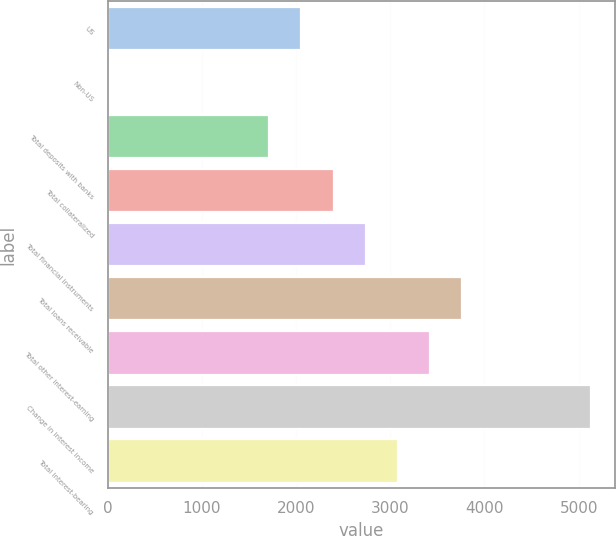<chart> <loc_0><loc_0><loc_500><loc_500><bar_chart><fcel>US<fcel>Non-US<fcel>Total deposits with banks<fcel>Total collateralized<fcel>Total financial instruments<fcel>Total loans receivable<fcel>Total other interest-earning<fcel>Change in interest income<fcel>Total interest-bearing<nl><fcel>2057.6<fcel>11<fcel>1716.5<fcel>2398.7<fcel>2739.8<fcel>3763.1<fcel>3422<fcel>5127.5<fcel>3080.9<nl></chart> 